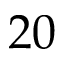<formula> <loc_0><loc_0><loc_500><loc_500>2 0</formula> 